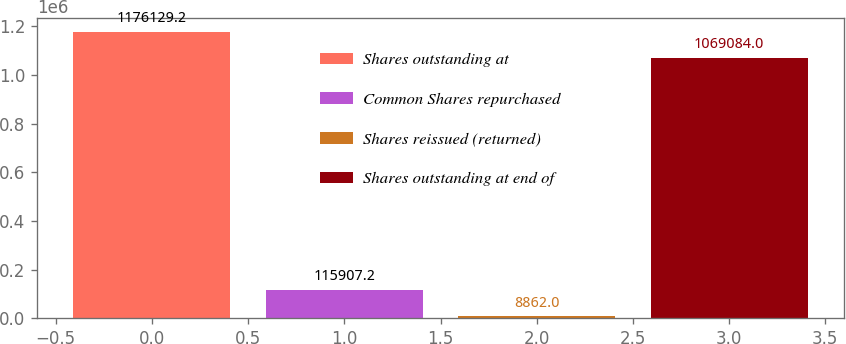Convert chart. <chart><loc_0><loc_0><loc_500><loc_500><bar_chart><fcel>Shares outstanding at<fcel>Common Shares repurchased<fcel>Shares reissued (returned)<fcel>Shares outstanding at end of<nl><fcel>1.17613e+06<fcel>115907<fcel>8862<fcel>1.06908e+06<nl></chart> 